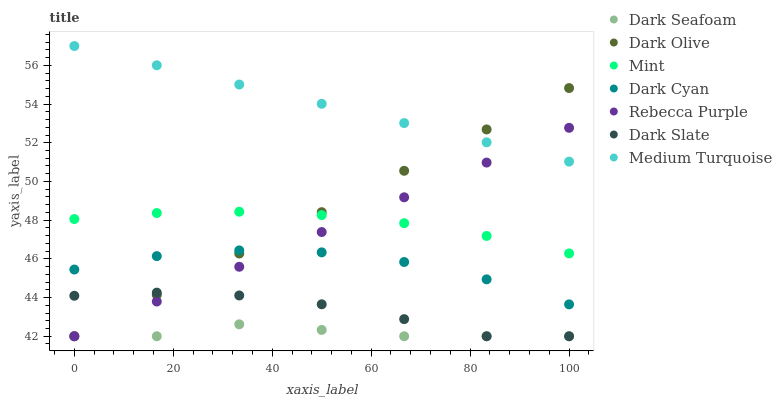Does Dark Seafoam have the minimum area under the curve?
Answer yes or no. Yes. Does Medium Turquoise have the maximum area under the curve?
Answer yes or no. Yes. Does Dark Slate have the minimum area under the curve?
Answer yes or no. No. Does Dark Slate have the maximum area under the curve?
Answer yes or no. No. Is Medium Turquoise the smoothest?
Answer yes or no. Yes. Is Dark Cyan the roughest?
Answer yes or no. Yes. Is Dark Slate the smoothest?
Answer yes or no. No. Is Dark Slate the roughest?
Answer yes or no. No. Does Dark Olive have the lowest value?
Answer yes or no. Yes. Does Medium Turquoise have the lowest value?
Answer yes or no. No. Does Medium Turquoise have the highest value?
Answer yes or no. Yes. Does Dark Slate have the highest value?
Answer yes or no. No. Is Dark Slate less than Dark Cyan?
Answer yes or no. Yes. Is Dark Cyan greater than Dark Seafoam?
Answer yes or no. Yes. Does Dark Seafoam intersect Dark Slate?
Answer yes or no. Yes. Is Dark Seafoam less than Dark Slate?
Answer yes or no. No. Is Dark Seafoam greater than Dark Slate?
Answer yes or no. No. Does Dark Slate intersect Dark Cyan?
Answer yes or no. No. 